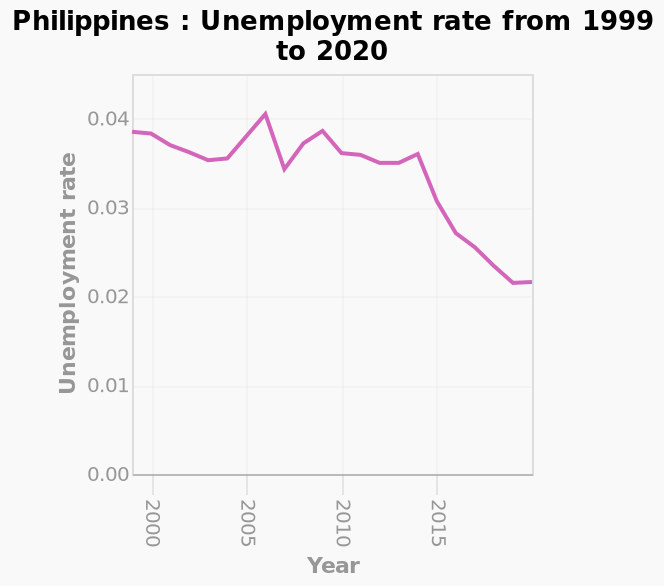<image>
please summary the statistics and relations of the chart The unemployment rate trended downwards from 1999 to 2020, from 0.04 to 0.021. What was the unemployment rate in 1999? The unemployment rate in 1999 was 0.04. 